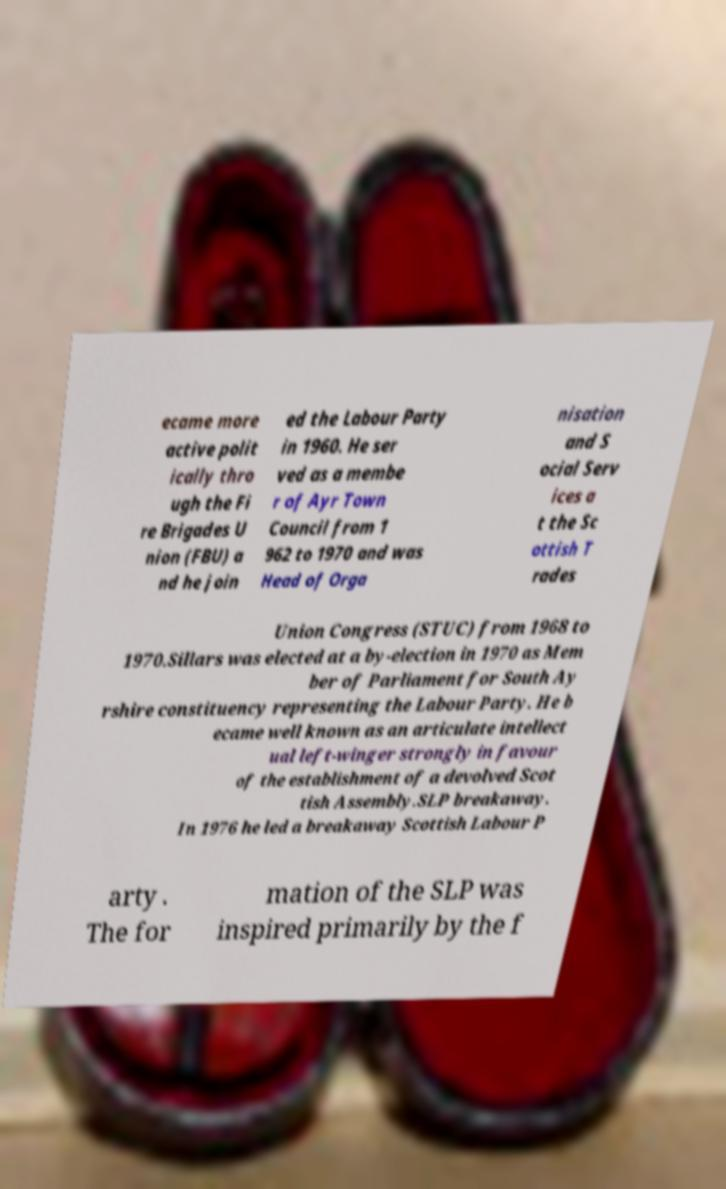What messages or text are displayed in this image? I need them in a readable, typed format. ecame more active polit ically thro ugh the Fi re Brigades U nion (FBU) a nd he join ed the Labour Party in 1960. He ser ved as a membe r of Ayr Town Council from 1 962 to 1970 and was Head of Orga nisation and S ocial Serv ices a t the Sc ottish T rades Union Congress (STUC) from 1968 to 1970.Sillars was elected at a by-election in 1970 as Mem ber of Parliament for South Ay rshire constituency representing the Labour Party. He b ecame well known as an articulate intellect ual left-winger strongly in favour of the establishment of a devolved Scot tish Assembly.SLP breakaway. In 1976 he led a breakaway Scottish Labour P arty . The for mation of the SLP was inspired primarily by the f 